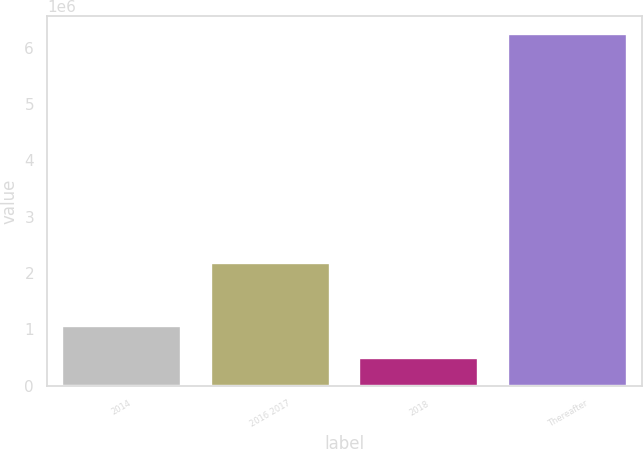<chart> <loc_0><loc_0><loc_500><loc_500><bar_chart><fcel>2014<fcel>2016 2017<fcel>2018<fcel>Thereafter<nl><fcel>1.06823e+06<fcel>2.18343e+06<fcel>492500<fcel>6.24982e+06<nl></chart> 